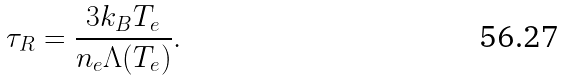<formula> <loc_0><loc_0><loc_500><loc_500>\tau _ { R } = \frac { 3 k _ { B } T _ { e } } { n _ { e } \Lambda ( T _ { e } ) } .</formula> 